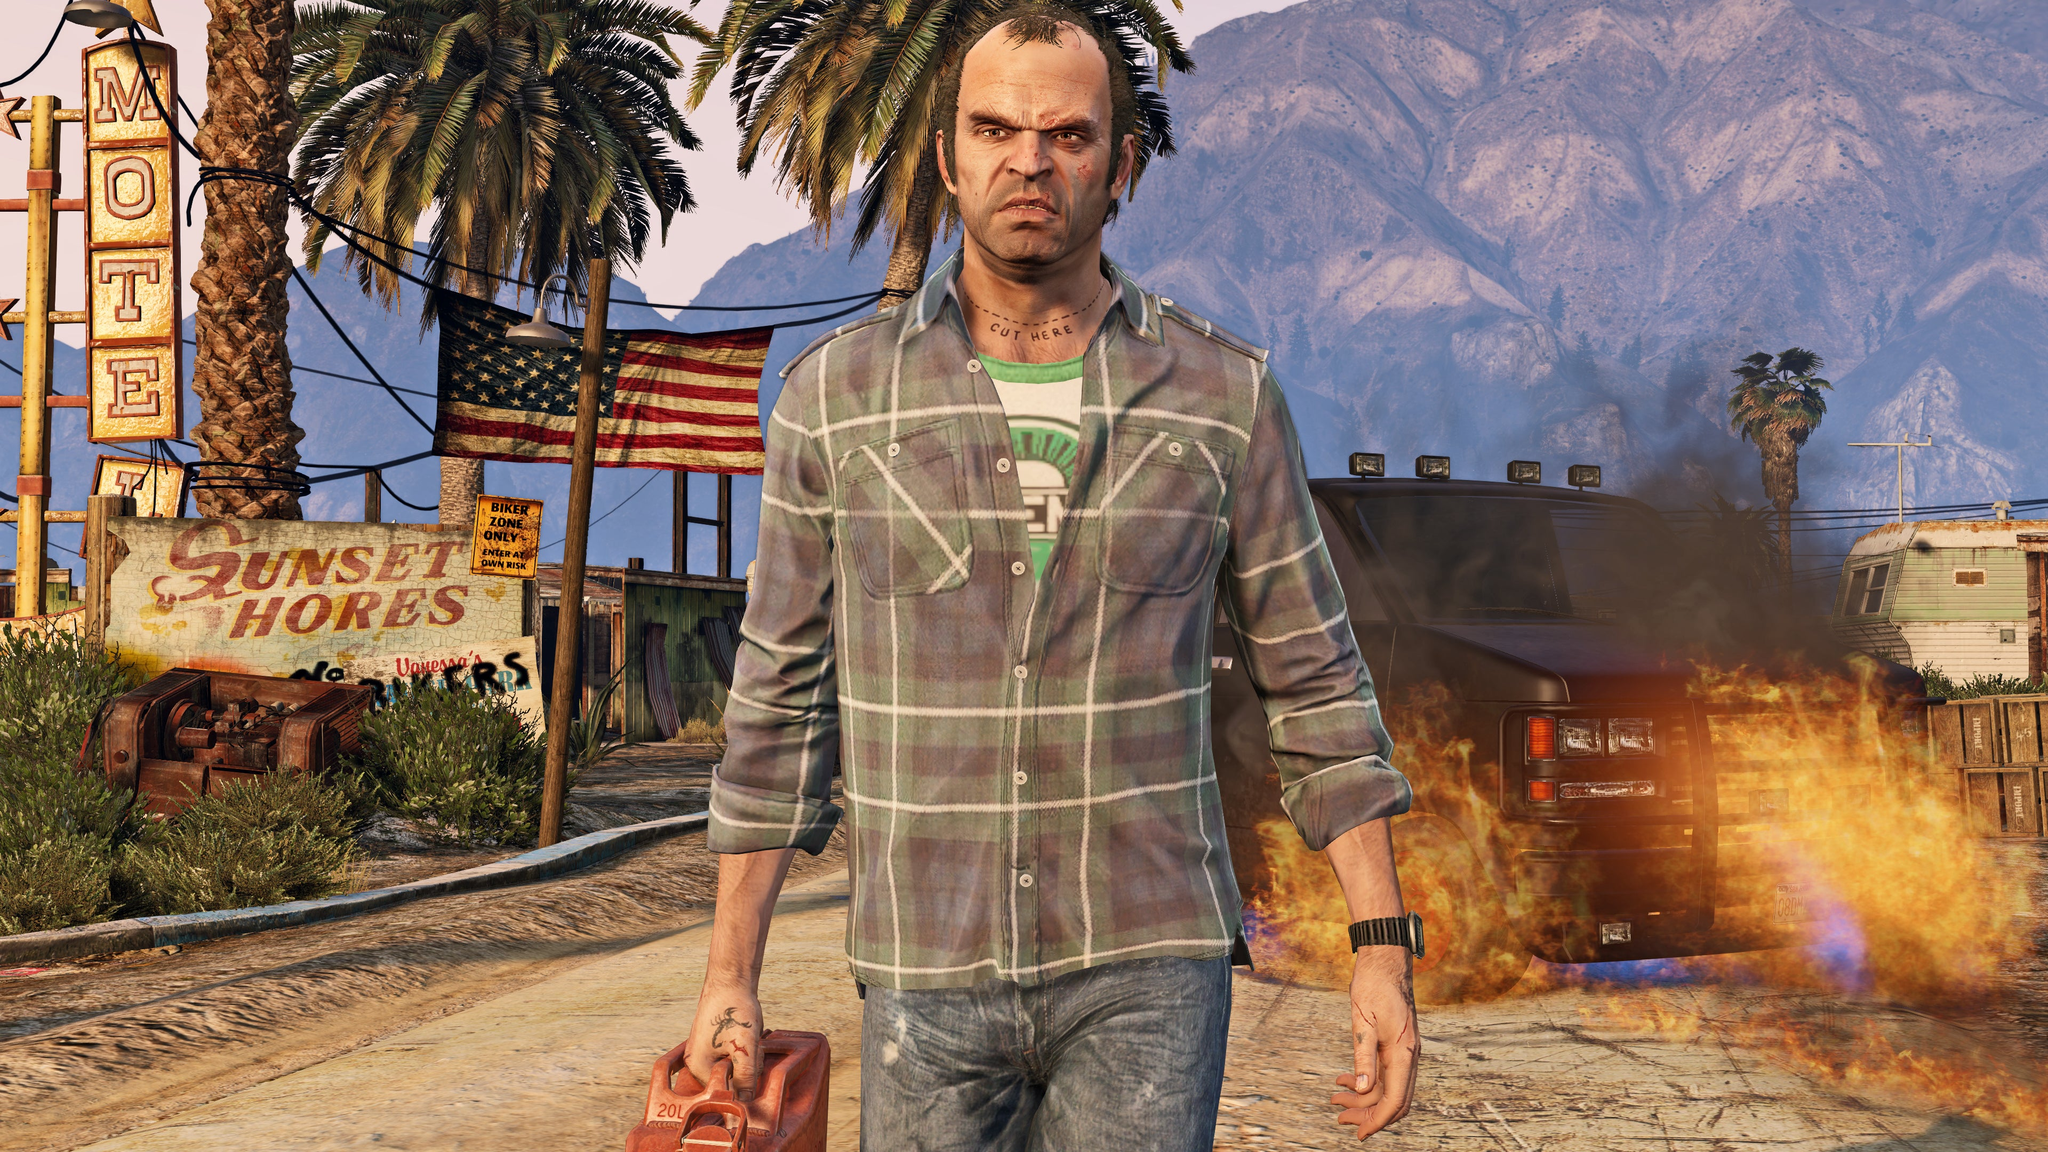Create a long, detailed scenario involving the person and the setting. In a detailed scenario, the man is a war veteran returning to his hometown on a mission to rescue his friends trapped by a ruthless gang overtaking the town. He walks with determination, carrying a gas can for a makeshift explosive. The scene around him tells stories of loss and conflict with the unattended fires and the dilapidated motel sign. As he advances, he recalls his past – fragmented memories of a prosperous town, now a ghost of its former self due to economic downfall and criminal exploitation. The man’s tattoos hint at significant battles and personal losses. He has learned through underground networks that his friends, who stayed to defend their land, are being held captive by the gang. His return isn't just about rescue but also about finding redemption. He moves stealthily, using the decayed structures for cover, inching closer to the gang’s hideout. Along the way, he encounters remnants of his past life – abandoned shops, graffiti marking gang territories, and signs of previous skirmishes. The background mountains, once a symbol of serenity, now stand as silent witnesses of the turmoil below. His quest is not just physical but metaphysical, challenging the inner demons that war inflicted upon him, seeking to restore justice and hope to a place that once knew peace. The desolate town encapsulates his inner struggles, making his mission an allegory for his path to healing and reclaiming his lost identity. 